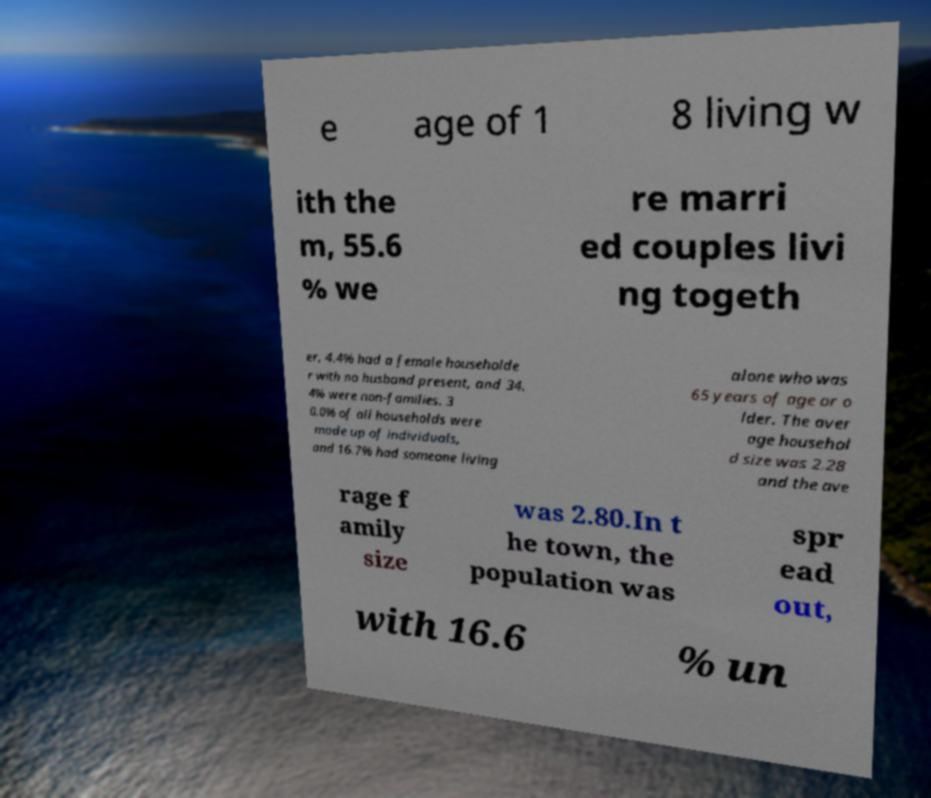Can you read and provide the text displayed in the image?This photo seems to have some interesting text. Can you extract and type it out for me? e age of 1 8 living w ith the m, 55.6 % we re marri ed couples livi ng togeth er, 4.4% had a female householde r with no husband present, and 34. 4% were non-families. 3 0.0% of all households were made up of individuals, and 16.7% had someone living alone who was 65 years of age or o lder. The aver age househol d size was 2.28 and the ave rage f amily size was 2.80.In t he town, the population was spr ead out, with 16.6 % un 